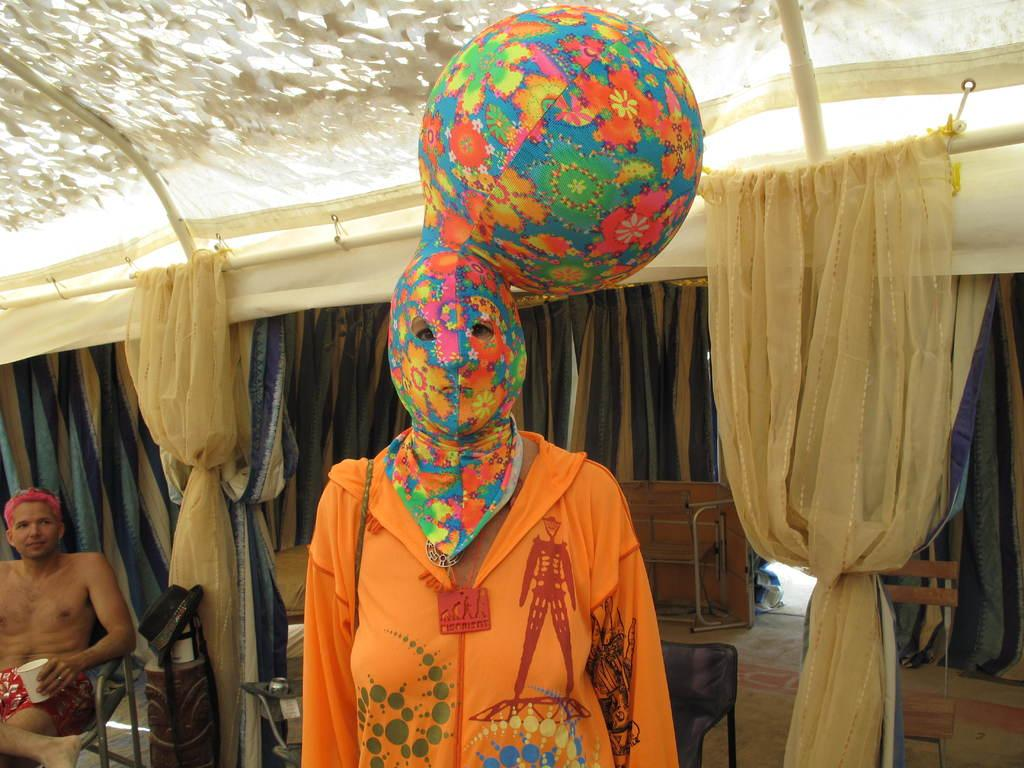How many people are present in the image? There are two persons in the image. Can you describe the background of the image? In the background of the image, there are clothes hanging on a rod. What type of letters are being exchanged between the two persons in the image? There is no indication in the image that the two persons are exchanging letters. 